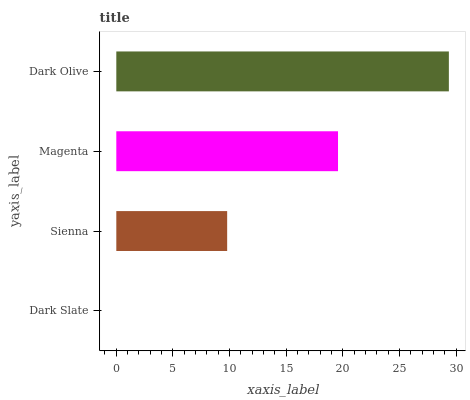Is Dark Slate the minimum?
Answer yes or no. Yes. Is Dark Olive the maximum?
Answer yes or no. Yes. Is Sienna the minimum?
Answer yes or no. No. Is Sienna the maximum?
Answer yes or no. No. Is Sienna greater than Dark Slate?
Answer yes or no. Yes. Is Dark Slate less than Sienna?
Answer yes or no. Yes. Is Dark Slate greater than Sienna?
Answer yes or no. No. Is Sienna less than Dark Slate?
Answer yes or no. No. Is Magenta the high median?
Answer yes or no. Yes. Is Sienna the low median?
Answer yes or no. Yes. Is Dark Slate the high median?
Answer yes or no. No. Is Dark Olive the low median?
Answer yes or no. No. 